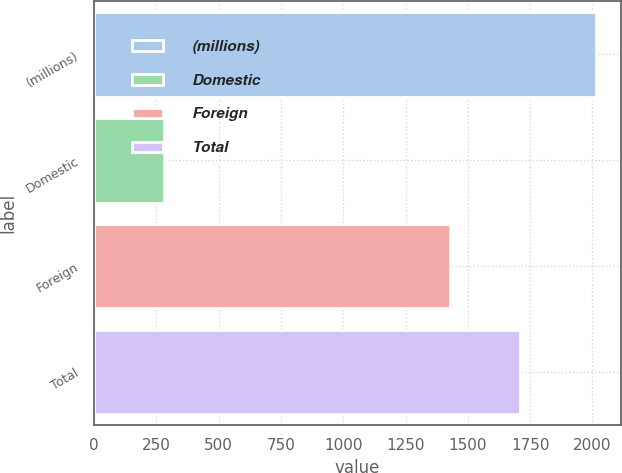Convert chart to OTSL. <chart><loc_0><loc_0><loc_500><loc_500><bar_chart><fcel>(millions)<fcel>Domestic<fcel>Foreign<fcel>Total<nl><fcel>2014<fcel>282<fcel>1428<fcel>1710<nl></chart> 